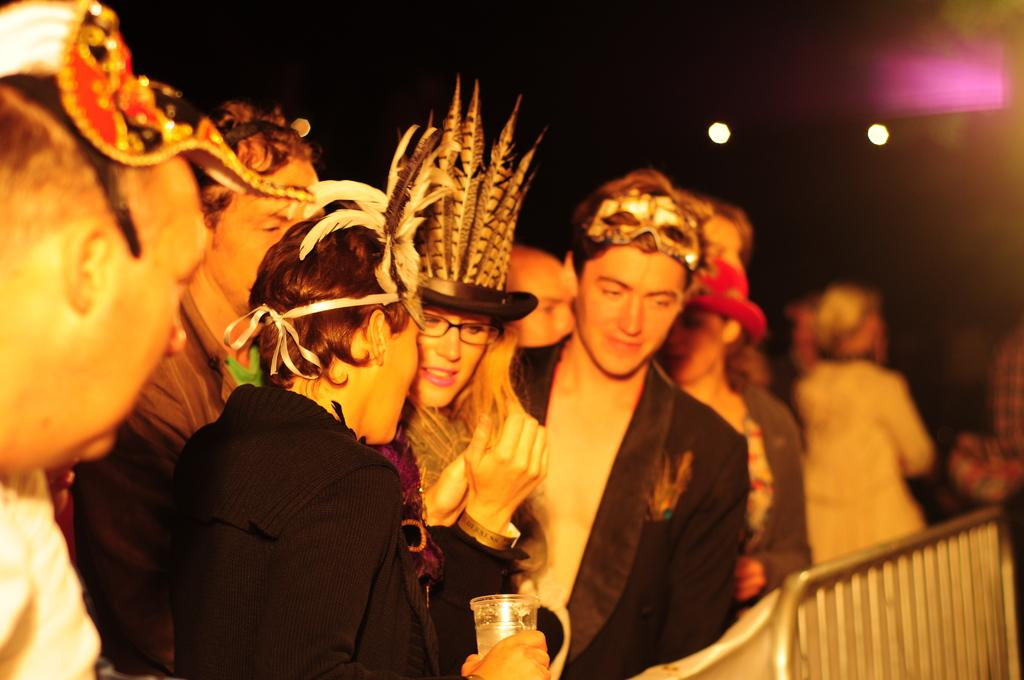What can be observed about the people in the image? There are groups of people in the image, and they are wearing masks. What is in front of the people in the image? There is a barrier in front of the people in the image. How would you describe the lighting in the image? The background of the image is dark, but there are lights visible in the image. What is the cause of the zebra's stripes in the image? There is no zebra present in the image, so the cause of its stripes cannot be determined. 